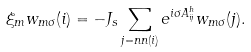<formula> <loc_0><loc_0><loc_500><loc_500>\xi _ { m } w _ { m \sigma } ( i ) = - J _ { s } \sum _ { j = n n ( i ) } e ^ { i \sigma A _ { i j } ^ { h } } w _ { m \sigma } ( j ) .</formula> 